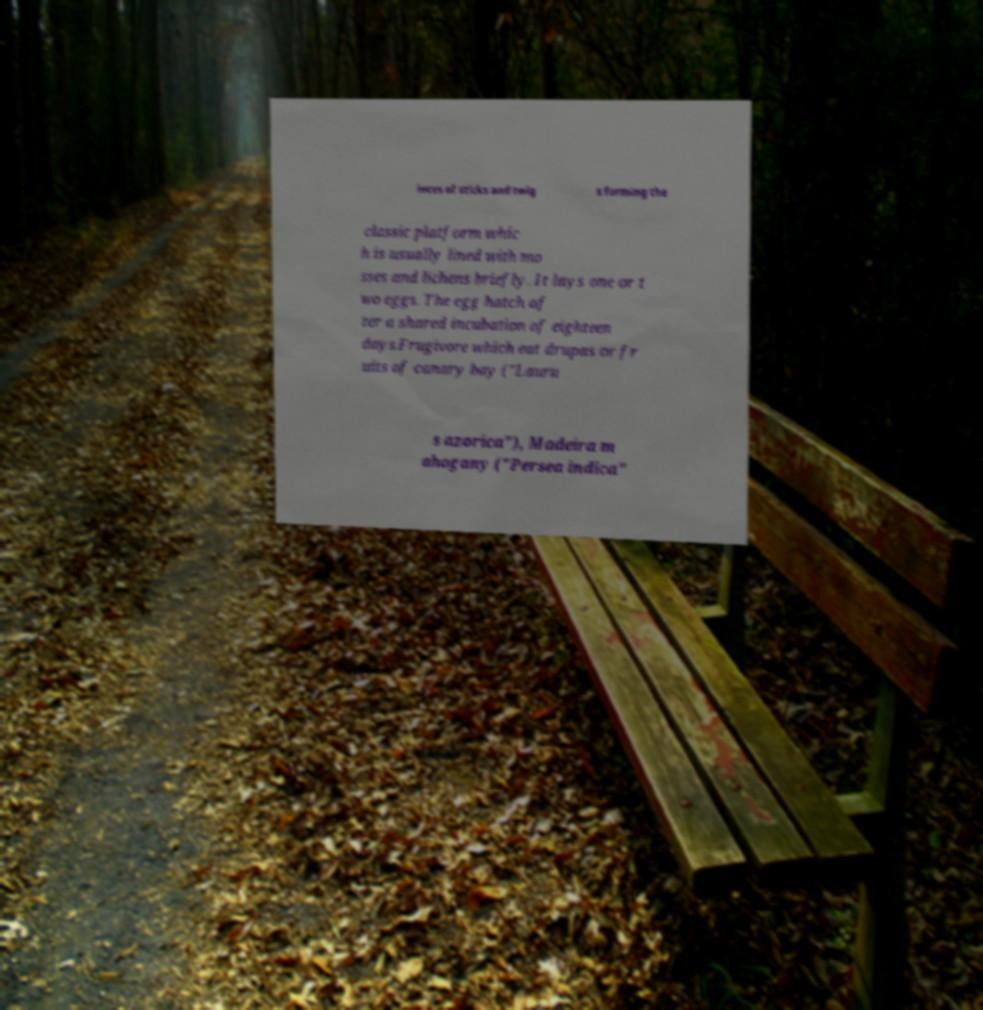For documentation purposes, I need the text within this image transcribed. Could you provide that? ieces of sticks and twig s forming the classic platform whic h is usually lined with mo sses and lichens briefly. It lays one or t wo eggs. The egg hatch af ter a shared incubation of eighteen days.Frugivore which eat drupas or fr uits of canary bay ("Lauru s azorica"), Madeira m ahogany ("Persea indica" 